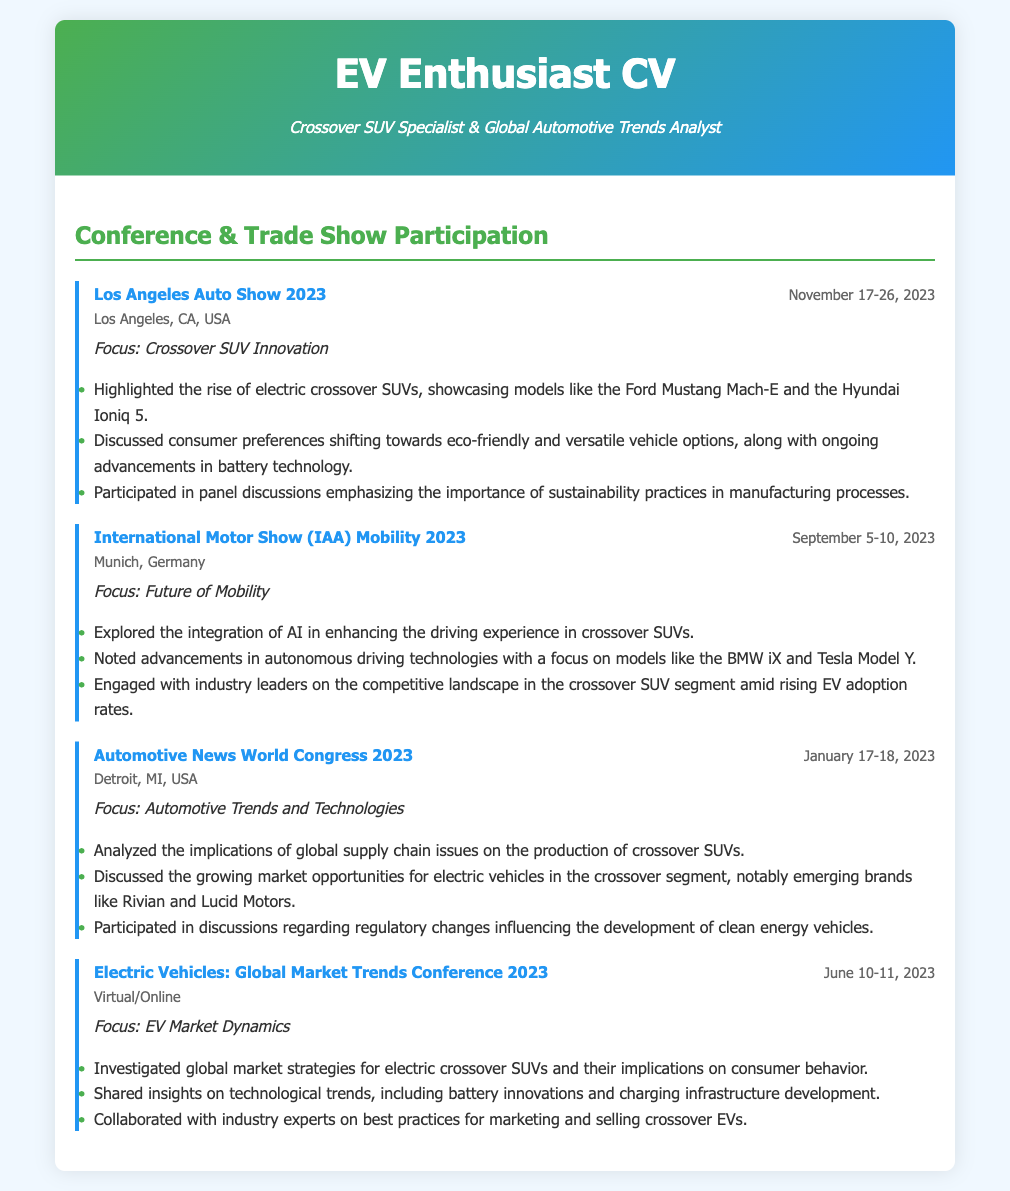What was the focus of the Los Angeles Auto Show 2023? The focus of the Los Angeles Auto Show 2023 was on Crossover SUV Innovation as indicated in the document.
Answer: Crossover SUV Innovation When did the International Motor Show (IAA) Mobility 2023 take place? The date range for the International Motor Show (IAA) Mobility 2023 is specified in the document as September 5-10, 2023.
Answer: September 5-10, 2023 In which city was the Automotive News World Congress 2023 held? The city for the Automotive News World Congress 2023 is clearly mentioned in the document as Detroit, MI, USA.
Answer: Detroit, MI, USA What type of technologies were discussed at the Automotive News World Congress 2023? The document states that discussions included implications of global supply chain issues and market opportunities for electric vehicles.
Answer: Global supply chain issues Which electric crossover SUV models were highlighted at the Los Angeles Auto Show 2023? According to the document, the highlighted models mentioned include the Ford Mustang Mach-E and the Hyundai Ioniq 5.
Answer: Ford Mustang Mach-E and Hyundai Ioniq 5 What was emphasized during the Electric Vehicles: Global Market Trends Conference 2023? The document indicates a focus on investigating global market strategies for electric crossover SUVs and insights on technological trends.
Answer: Global market strategies How many events are listed in the Conference & Trade Show Participation section? The document enumerates a total of four events listed under the Conference & Trade Show Participation section.
Answer: Four events Which focus was central during the International Motor Show (IAA) Mobility 2023? The document specifies that the focus during the International Motor Show was on the Future of Mobility.
Answer: Future of Mobility How did the document categorize the participant's role in the automotive sector? The document elaborated that the individual is a Crossover SUV Specialist & Global Automotive Trends Analyst.
Answer: Crossover SUV Specialist & Global Automotive Trends Analyst 